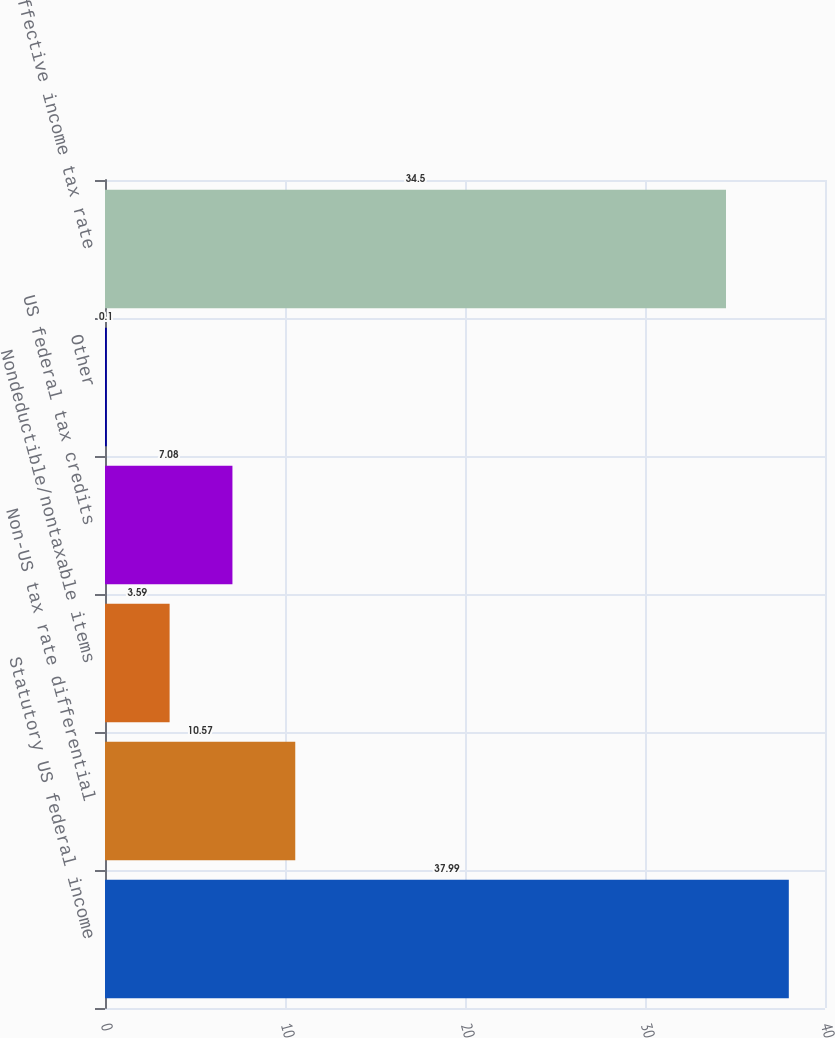Convert chart to OTSL. <chart><loc_0><loc_0><loc_500><loc_500><bar_chart><fcel>Statutory US federal income<fcel>Non-US tax rate differential<fcel>Nondeductible/nontaxable items<fcel>US federal tax credits<fcel>Other<fcel>Effective income tax rate<nl><fcel>37.99<fcel>10.57<fcel>3.59<fcel>7.08<fcel>0.1<fcel>34.5<nl></chart> 